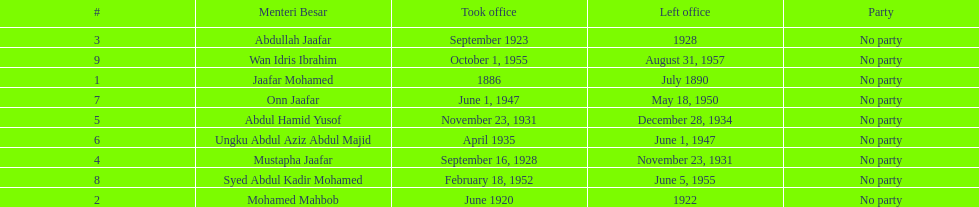Can you give me this table as a dict? {'header': ['#', 'Menteri Besar', 'Took office', 'Left office', 'Party'], 'rows': [['3', 'Abdullah Jaafar', 'September 1923', '1928', 'No party'], ['9', 'Wan Idris Ibrahim', 'October 1, 1955', 'August 31, 1957', 'No party'], ['1', 'Jaafar Mohamed', '1886', 'July 1890', 'No party'], ['7', 'Onn Jaafar', 'June 1, 1947', 'May 18, 1950', 'No party'], ['5', 'Abdul Hamid Yusof', 'November 23, 1931', 'December 28, 1934', 'No party'], ['6', 'Ungku Abdul Aziz Abdul Majid', 'April 1935', 'June 1, 1947', 'No party'], ['4', 'Mustapha Jaafar', 'September 16, 1928', 'November 23, 1931', 'No party'], ['8', 'Syed Abdul Kadir Mohamed', 'February 18, 1952', 'June 5, 1955', 'No party'], ['2', 'Mohamed Mahbob', 'June 1920', '1922', 'No party']]} How many years was jaafar mohamed in office? 4. 